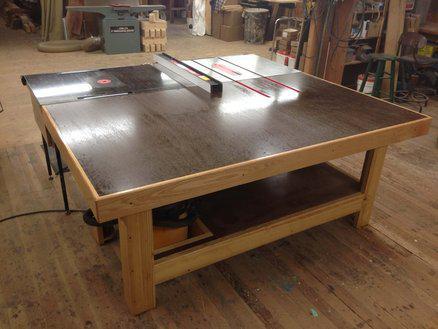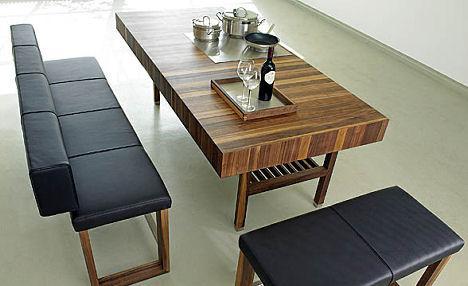The first image is the image on the left, the second image is the image on the right. Assess this claim about the two images: "There is nothing on the table in the image on the left". Correct or not? Answer yes or no. No. The first image is the image on the left, the second image is the image on the right. Assess this claim about the two images: "A rectangular wooden dining table is shown with at least four chairs in one image.". Correct or not? Answer yes or no. No. 